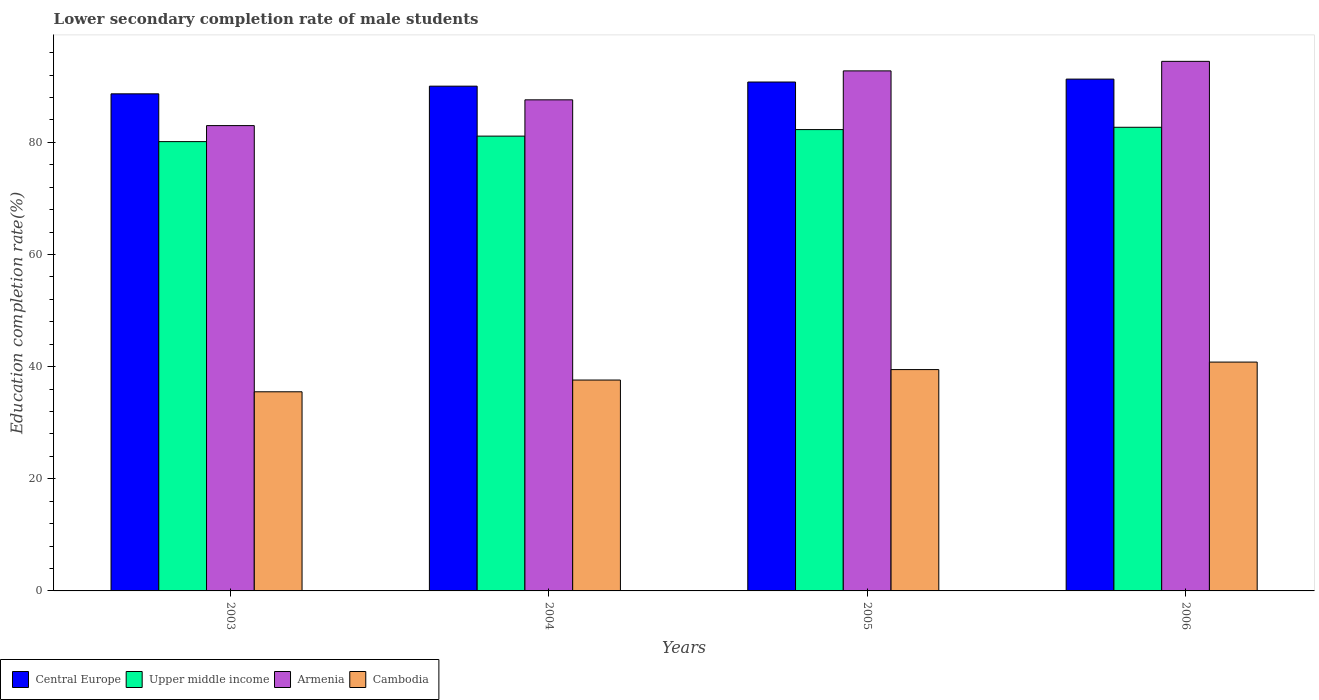How many different coloured bars are there?
Your answer should be compact. 4. What is the label of the 4th group of bars from the left?
Give a very brief answer. 2006. In how many cases, is the number of bars for a given year not equal to the number of legend labels?
Provide a short and direct response. 0. What is the lower secondary completion rate of male students in Armenia in 2003?
Your answer should be very brief. 82.98. Across all years, what is the maximum lower secondary completion rate of male students in Central Europe?
Give a very brief answer. 91.27. Across all years, what is the minimum lower secondary completion rate of male students in Upper middle income?
Your response must be concise. 80.13. In which year was the lower secondary completion rate of male students in Cambodia minimum?
Provide a succinct answer. 2003. What is the total lower secondary completion rate of male students in Armenia in the graph?
Ensure brevity in your answer.  357.73. What is the difference between the lower secondary completion rate of male students in Upper middle income in 2004 and that in 2005?
Give a very brief answer. -1.17. What is the difference between the lower secondary completion rate of male students in Armenia in 2003 and the lower secondary completion rate of male students in Central Europe in 2006?
Your answer should be very brief. -8.29. What is the average lower secondary completion rate of male students in Armenia per year?
Your answer should be compact. 89.43. In the year 2006, what is the difference between the lower secondary completion rate of male students in Upper middle income and lower secondary completion rate of male students in Central Europe?
Give a very brief answer. -8.59. In how many years, is the lower secondary completion rate of male students in Central Europe greater than 56 %?
Offer a terse response. 4. What is the ratio of the lower secondary completion rate of male students in Armenia in 2004 to that in 2006?
Offer a very short reply. 0.93. Is the lower secondary completion rate of male students in Cambodia in 2004 less than that in 2006?
Your answer should be compact. Yes. Is the difference between the lower secondary completion rate of male students in Upper middle income in 2004 and 2005 greater than the difference between the lower secondary completion rate of male students in Central Europe in 2004 and 2005?
Provide a succinct answer. No. What is the difference between the highest and the second highest lower secondary completion rate of male students in Central Europe?
Provide a short and direct response. 0.52. What is the difference between the highest and the lowest lower secondary completion rate of male students in Armenia?
Ensure brevity in your answer.  11.46. In how many years, is the lower secondary completion rate of male students in Cambodia greater than the average lower secondary completion rate of male students in Cambodia taken over all years?
Keep it short and to the point. 2. Is it the case that in every year, the sum of the lower secondary completion rate of male students in Cambodia and lower secondary completion rate of male students in Armenia is greater than the sum of lower secondary completion rate of male students in Central Europe and lower secondary completion rate of male students in Upper middle income?
Provide a succinct answer. No. What does the 4th bar from the left in 2004 represents?
Provide a succinct answer. Cambodia. What does the 4th bar from the right in 2003 represents?
Offer a very short reply. Central Europe. Is it the case that in every year, the sum of the lower secondary completion rate of male students in Upper middle income and lower secondary completion rate of male students in Central Europe is greater than the lower secondary completion rate of male students in Cambodia?
Keep it short and to the point. Yes. How many years are there in the graph?
Keep it short and to the point. 4. Are the values on the major ticks of Y-axis written in scientific E-notation?
Give a very brief answer. No. Does the graph contain any zero values?
Your response must be concise. No. Does the graph contain grids?
Provide a short and direct response. No. How many legend labels are there?
Your answer should be very brief. 4. How are the legend labels stacked?
Offer a terse response. Horizontal. What is the title of the graph?
Give a very brief answer. Lower secondary completion rate of male students. What is the label or title of the X-axis?
Ensure brevity in your answer.  Years. What is the label or title of the Y-axis?
Ensure brevity in your answer.  Education completion rate(%). What is the Education completion rate(%) of Central Europe in 2003?
Your answer should be compact. 88.65. What is the Education completion rate(%) in Upper middle income in 2003?
Give a very brief answer. 80.13. What is the Education completion rate(%) of Armenia in 2003?
Provide a short and direct response. 82.98. What is the Education completion rate(%) in Cambodia in 2003?
Your answer should be very brief. 35.51. What is the Education completion rate(%) in Central Europe in 2004?
Keep it short and to the point. 90.01. What is the Education completion rate(%) in Upper middle income in 2004?
Make the answer very short. 81.11. What is the Education completion rate(%) of Armenia in 2004?
Your answer should be compact. 87.57. What is the Education completion rate(%) of Cambodia in 2004?
Offer a terse response. 37.61. What is the Education completion rate(%) of Central Europe in 2005?
Your answer should be very brief. 90.75. What is the Education completion rate(%) of Upper middle income in 2005?
Your answer should be compact. 82.27. What is the Education completion rate(%) in Armenia in 2005?
Make the answer very short. 92.74. What is the Education completion rate(%) of Cambodia in 2005?
Give a very brief answer. 39.47. What is the Education completion rate(%) in Central Europe in 2006?
Offer a very short reply. 91.27. What is the Education completion rate(%) of Upper middle income in 2006?
Ensure brevity in your answer.  82.68. What is the Education completion rate(%) of Armenia in 2006?
Offer a terse response. 94.44. What is the Education completion rate(%) of Cambodia in 2006?
Give a very brief answer. 40.81. Across all years, what is the maximum Education completion rate(%) in Central Europe?
Your answer should be very brief. 91.27. Across all years, what is the maximum Education completion rate(%) of Upper middle income?
Offer a terse response. 82.68. Across all years, what is the maximum Education completion rate(%) in Armenia?
Offer a very short reply. 94.44. Across all years, what is the maximum Education completion rate(%) in Cambodia?
Your response must be concise. 40.81. Across all years, what is the minimum Education completion rate(%) in Central Europe?
Make the answer very short. 88.65. Across all years, what is the minimum Education completion rate(%) of Upper middle income?
Ensure brevity in your answer.  80.13. Across all years, what is the minimum Education completion rate(%) of Armenia?
Your response must be concise. 82.98. Across all years, what is the minimum Education completion rate(%) of Cambodia?
Offer a terse response. 35.51. What is the total Education completion rate(%) in Central Europe in the graph?
Make the answer very short. 360.69. What is the total Education completion rate(%) in Upper middle income in the graph?
Your response must be concise. 326.18. What is the total Education completion rate(%) of Armenia in the graph?
Your answer should be compact. 357.73. What is the total Education completion rate(%) of Cambodia in the graph?
Ensure brevity in your answer.  153.4. What is the difference between the Education completion rate(%) in Central Europe in 2003 and that in 2004?
Provide a short and direct response. -1.37. What is the difference between the Education completion rate(%) of Upper middle income in 2003 and that in 2004?
Provide a succinct answer. -0.98. What is the difference between the Education completion rate(%) of Armenia in 2003 and that in 2004?
Your response must be concise. -4.59. What is the difference between the Education completion rate(%) of Cambodia in 2003 and that in 2004?
Your answer should be very brief. -2.1. What is the difference between the Education completion rate(%) of Central Europe in 2003 and that in 2005?
Provide a short and direct response. -2.11. What is the difference between the Education completion rate(%) in Upper middle income in 2003 and that in 2005?
Make the answer very short. -2.14. What is the difference between the Education completion rate(%) of Armenia in 2003 and that in 2005?
Make the answer very short. -9.76. What is the difference between the Education completion rate(%) of Cambodia in 2003 and that in 2005?
Keep it short and to the point. -3.96. What is the difference between the Education completion rate(%) in Central Europe in 2003 and that in 2006?
Provide a succinct answer. -2.63. What is the difference between the Education completion rate(%) of Upper middle income in 2003 and that in 2006?
Your answer should be very brief. -2.56. What is the difference between the Education completion rate(%) of Armenia in 2003 and that in 2006?
Your answer should be compact. -11.46. What is the difference between the Education completion rate(%) in Cambodia in 2003 and that in 2006?
Give a very brief answer. -5.3. What is the difference between the Education completion rate(%) of Central Europe in 2004 and that in 2005?
Provide a succinct answer. -0.74. What is the difference between the Education completion rate(%) in Upper middle income in 2004 and that in 2005?
Offer a very short reply. -1.17. What is the difference between the Education completion rate(%) of Armenia in 2004 and that in 2005?
Give a very brief answer. -5.16. What is the difference between the Education completion rate(%) in Cambodia in 2004 and that in 2005?
Make the answer very short. -1.86. What is the difference between the Education completion rate(%) in Central Europe in 2004 and that in 2006?
Provide a short and direct response. -1.26. What is the difference between the Education completion rate(%) of Upper middle income in 2004 and that in 2006?
Provide a short and direct response. -1.58. What is the difference between the Education completion rate(%) in Armenia in 2004 and that in 2006?
Your response must be concise. -6.86. What is the difference between the Education completion rate(%) in Cambodia in 2004 and that in 2006?
Give a very brief answer. -3.2. What is the difference between the Education completion rate(%) of Central Europe in 2005 and that in 2006?
Give a very brief answer. -0.52. What is the difference between the Education completion rate(%) in Upper middle income in 2005 and that in 2006?
Offer a terse response. -0.41. What is the difference between the Education completion rate(%) in Armenia in 2005 and that in 2006?
Keep it short and to the point. -1.7. What is the difference between the Education completion rate(%) in Cambodia in 2005 and that in 2006?
Your answer should be compact. -1.34. What is the difference between the Education completion rate(%) of Central Europe in 2003 and the Education completion rate(%) of Upper middle income in 2004?
Provide a short and direct response. 7.54. What is the difference between the Education completion rate(%) of Central Europe in 2003 and the Education completion rate(%) of Armenia in 2004?
Provide a succinct answer. 1.07. What is the difference between the Education completion rate(%) of Central Europe in 2003 and the Education completion rate(%) of Cambodia in 2004?
Make the answer very short. 51.04. What is the difference between the Education completion rate(%) in Upper middle income in 2003 and the Education completion rate(%) in Armenia in 2004?
Keep it short and to the point. -7.45. What is the difference between the Education completion rate(%) of Upper middle income in 2003 and the Education completion rate(%) of Cambodia in 2004?
Your answer should be very brief. 42.52. What is the difference between the Education completion rate(%) in Armenia in 2003 and the Education completion rate(%) in Cambodia in 2004?
Ensure brevity in your answer.  45.37. What is the difference between the Education completion rate(%) of Central Europe in 2003 and the Education completion rate(%) of Upper middle income in 2005?
Your answer should be very brief. 6.38. What is the difference between the Education completion rate(%) of Central Europe in 2003 and the Education completion rate(%) of Armenia in 2005?
Keep it short and to the point. -4.09. What is the difference between the Education completion rate(%) of Central Europe in 2003 and the Education completion rate(%) of Cambodia in 2005?
Ensure brevity in your answer.  49.18. What is the difference between the Education completion rate(%) of Upper middle income in 2003 and the Education completion rate(%) of Armenia in 2005?
Provide a succinct answer. -12.61. What is the difference between the Education completion rate(%) of Upper middle income in 2003 and the Education completion rate(%) of Cambodia in 2005?
Offer a very short reply. 40.66. What is the difference between the Education completion rate(%) in Armenia in 2003 and the Education completion rate(%) in Cambodia in 2005?
Make the answer very short. 43.51. What is the difference between the Education completion rate(%) of Central Europe in 2003 and the Education completion rate(%) of Upper middle income in 2006?
Your response must be concise. 5.96. What is the difference between the Education completion rate(%) in Central Europe in 2003 and the Education completion rate(%) in Armenia in 2006?
Keep it short and to the point. -5.79. What is the difference between the Education completion rate(%) of Central Europe in 2003 and the Education completion rate(%) of Cambodia in 2006?
Offer a terse response. 47.84. What is the difference between the Education completion rate(%) in Upper middle income in 2003 and the Education completion rate(%) in Armenia in 2006?
Keep it short and to the point. -14.31. What is the difference between the Education completion rate(%) of Upper middle income in 2003 and the Education completion rate(%) of Cambodia in 2006?
Your answer should be compact. 39.32. What is the difference between the Education completion rate(%) of Armenia in 2003 and the Education completion rate(%) of Cambodia in 2006?
Offer a very short reply. 42.17. What is the difference between the Education completion rate(%) in Central Europe in 2004 and the Education completion rate(%) in Upper middle income in 2005?
Ensure brevity in your answer.  7.74. What is the difference between the Education completion rate(%) of Central Europe in 2004 and the Education completion rate(%) of Armenia in 2005?
Provide a succinct answer. -2.72. What is the difference between the Education completion rate(%) of Central Europe in 2004 and the Education completion rate(%) of Cambodia in 2005?
Offer a very short reply. 50.54. What is the difference between the Education completion rate(%) of Upper middle income in 2004 and the Education completion rate(%) of Armenia in 2005?
Your response must be concise. -11.63. What is the difference between the Education completion rate(%) of Upper middle income in 2004 and the Education completion rate(%) of Cambodia in 2005?
Your answer should be compact. 41.64. What is the difference between the Education completion rate(%) of Armenia in 2004 and the Education completion rate(%) of Cambodia in 2005?
Provide a short and direct response. 48.1. What is the difference between the Education completion rate(%) of Central Europe in 2004 and the Education completion rate(%) of Upper middle income in 2006?
Make the answer very short. 7.33. What is the difference between the Education completion rate(%) of Central Europe in 2004 and the Education completion rate(%) of Armenia in 2006?
Offer a very short reply. -4.42. What is the difference between the Education completion rate(%) of Central Europe in 2004 and the Education completion rate(%) of Cambodia in 2006?
Provide a succinct answer. 49.21. What is the difference between the Education completion rate(%) of Upper middle income in 2004 and the Education completion rate(%) of Armenia in 2006?
Give a very brief answer. -13.33. What is the difference between the Education completion rate(%) in Upper middle income in 2004 and the Education completion rate(%) in Cambodia in 2006?
Ensure brevity in your answer.  40.3. What is the difference between the Education completion rate(%) of Armenia in 2004 and the Education completion rate(%) of Cambodia in 2006?
Keep it short and to the point. 46.77. What is the difference between the Education completion rate(%) in Central Europe in 2005 and the Education completion rate(%) in Upper middle income in 2006?
Provide a short and direct response. 8.07. What is the difference between the Education completion rate(%) in Central Europe in 2005 and the Education completion rate(%) in Armenia in 2006?
Your answer should be very brief. -3.69. What is the difference between the Education completion rate(%) in Central Europe in 2005 and the Education completion rate(%) in Cambodia in 2006?
Your answer should be compact. 49.95. What is the difference between the Education completion rate(%) of Upper middle income in 2005 and the Education completion rate(%) of Armenia in 2006?
Provide a succinct answer. -12.17. What is the difference between the Education completion rate(%) in Upper middle income in 2005 and the Education completion rate(%) in Cambodia in 2006?
Give a very brief answer. 41.46. What is the difference between the Education completion rate(%) of Armenia in 2005 and the Education completion rate(%) of Cambodia in 2006?
Give a very brief answer. 51.93. What is the average Education completion rate(%) in Central Europe per year?
Provide a succinct answer. 90.17. What is the average Education completion rate(%) of Upper middle income per year?
Keep it short and to the point. 81.55. What is the average Education completion rate(%) in Armenia per year?
Make the answer very short. 89.43. What is the average Education completion rate(%) in Cambodia per year?
Make the answer very short. 38.35. In the year 2003, what is the difference between the Education completion rate(%) in Central Europe and Education completion rate(%) in Upper middle income?
Offer a terse response. 8.52. In the year 2003, what is the difference between the Education completion rate(%) in Central Europe and Education completion rate(%) in Armenia?
Your response must be concise. 5.67. In the year 2003, what is the difference between the Education completion rate(%) in Central Europe and Education completion rate(%) in Cambodia?
Give a very brief answer. 53.14. In the year 2003, what is the difference between the Education completion rate(%) of Upper middle income and Education completion rate(%) of Armenia?
Ensure brevity in your answer.  -2.85. In the year 2003, what is the difference between the Education completion rate(%) in Upper middle income and Education completion rate(%) in Cambodia?
Keep it short and to the point. 44.61. In the year 2003, what is the difference between the Education completion rate(%) in Armenia and Education completion rate(%) in Cambodia?
Provide a short and direct response. 47.47. In the year 2004, what is the difference between the Education completion rate(%) in Central Europe and Education completion rate(%) in Upper middle income?
Keep it short and to the point. 8.91. In the year 2004, what is the difference between the Education completion rate(%) in Central Europe and Education completion rate(%) in Armenia?
Give a very brief answer. 2.44. In the year 2004, what is the difference between the Education completion rate(%) of Central Europe and Education completion rate(%) of Cambodia?
Provide a short and direct response. 52.41. In the year 2004, what is the difference between the Education completion rate(%) of Upper middle income and Education completion rate(%) of Armenia?
Your answer should be compact. -6.47. In the year 2004, what is the difference between the Education completion rate(%) in Upper middle income and Education completion rate(%) in Cambodia?
Your answer should be very brief. 43.5. In the year 2004, what is the difference between the Education completion rate(%) in Armenia and Education completion rate(%) in Cambodia?
Offer a terse response. 49.97. In the year 2005, what is the difference between the Education completion rate(%) of Central Europe and Education completion rate(%) of Upper middle income?
Provide a short and direct response. 8.48. In the year 2005, what is the difference between the Education completion rate(%) in Central Europe and Education completion rate(%) in Armenia?
Your answer should be compact. -1.99. In the year 2005, what is the difference between the Education completion rate(%) in Central Europe and Education completion rate(%) in Cambodia?
Provide a succinct answer. 51.28. In the year 2005, what is the difference between the Education completion rate(%) in Upper middle income and Education completion rate(%) in Armenia?
Make the answer very short. -10.47. In the year 2005, what is the difference between the Education completion rate(%) of Upper middle income and Education completion rate(%) of Cambodia?
Provide a succinct answer. 42.8. In the year 2005, what is the difference between the Education completion rate(%) in Armenia and Education completion rate(%) in Cambodia?
Ensure brevity in your answer.  53.27. In the year 2006, what is the difference between the Education completion rate(%) of Central Europe and Education completion rate(%) of Upper middle income?
Offer a very short reply. 8.59. In the year 2006, what is the difference between the Education completion rate(%) in Central Europe and Education completion rate(%) in Armenia?
Ensure brevity in your answer.  -3.16. In the year 2006, what is the difference between the Education completion rate(%) of Central Europe and Education completion rate(%) of Cambodia?
Your answer should be very brief. 50.47. In the year 2006, what is the difference between the Education completion rate(%) of Upper middle income and Education completion rate(%) of Armenia?
Your answer should be very brief. -11.76. In the year 2006, what is the difference between the Education completion rate(%) in Upper middle income and Education completion rate(%) in Cambodia?
Offer a very short reply. 41.87. In the year 2006, what is the difference between the Education completion rate(%) in Armenia and Education completion rate(%) in Cambodia?
Provide a short and direct response. 53.63. What is the ratio of the Education completion rate(%) of Upper middle income in 2003 to that in 2004?
Ensure brevity in your answer.  0.99. What is the ratio of the Education completion rate(%) in Armenia in 2003 to that in 2004?
Make the answer very short. 0.95. What is the ratio of the Education completion rate(%) in Cambodia in 2003 to that in 2004?
Your response must be concise. 0.94. What is the ratio of the Education completion rate(%) of Central Europe in 2003 to that in 2005?
Your response must be concise. 0.98. What is the ratio of the Education completion rate(%) of Upper middle income in 2003 to that in 2005?
Ensure brevity in your answer.  0.97. What is the ratio of the Education completion rate(%) of Armenia in 2003 to that in 2005?
Make the answer very short. 0.89. What is the ratio of the Education completion rate(%) in Cambodia in 2003 to that in 2005?
Make the answer very short. 0.9. What is the ratio of the Education completion rate(%) of Central Europe in 2003 to that in 2006?
Give a very brief answer. 0.97. What is the ratio of the Education completion rate(%) in Upper middle income in 2003 to that in 2006?
Offer a very short reply. 0.97. What is the ratio of the Education completion rate(%) in Armenia in 2003 to that in 2006?
Make the answer very short. 0.88. What is the ratio of the Education completion rate(%) of Cambodia in 2003 to that in 2006?
Give a very brief answer. 0.87. What is the ratio of the Education completion rate(%) of Upper middle income in 2004 to that in 2005?
Ensure brevity in your answer.  0.99. What is the ratio of the Education completion rate(%) of Armenia in 2004 to that in 2005?
Your answer should be compact. 0.94. What is the ratio of the Education completion rate(%) of Cambodia in 2004 to that in 2005?
Give a very brief answer. 0.95. What is the ratio of the Education completion rate(%) of Central Europe in 2004 to that in 2006?
Your response must be concise. 0.99. What is the ratio of the Education completion rate(%) in Upper middle income in 2004 to that in 2006?
Your answer should be compact. 0.98. What is the ratio of the Education completion rate(%) of Armenia in 2004 to that in 2006?
Provide a short and direct response. 0.93. What is the ratio of the Education completion rate(%) of Cambodia in 2004 to that in 2006?
Offer a terse response. 0.92. What is the ratio of the Education completion rate(%) in Cambodia in 2005 to that in 2006?
Provide a succinct answer. 0.97. What is the difference between the highest and the second highest Education completion rate(%) in Central Europe?
Make the answer very short. 0.52. What is the difference between the highest and the second highest Education completion rate(%) of Upper middle income?
Ensure brevity in your answer.  0.41. What is the difference between the highest and the second highest Education completion rate(%) of Armenia?
Your answer should be compact. 1.7. What is the difference between the highest and the second highest Education completion rate(%) of Cambodia?
Ensure brevity in your answer.  1.34. What is the difference between the highest and the lowest Education completion rate(%) of Central Europe?
Your answer should be very brief. 2.63. What is the difference between the highest and the lowest Education completion rate(%) in Upper middle income?
Offer a very short reply. 2.56. What is the difference between the highest and the lowest Education completion rate(%) of Armenia?
Provide a succinct answer. 11.46. What is the difference between the highest and the lowest Education completion rate(%) of Cambodia?
Your answer should be very brief. 5.3. 